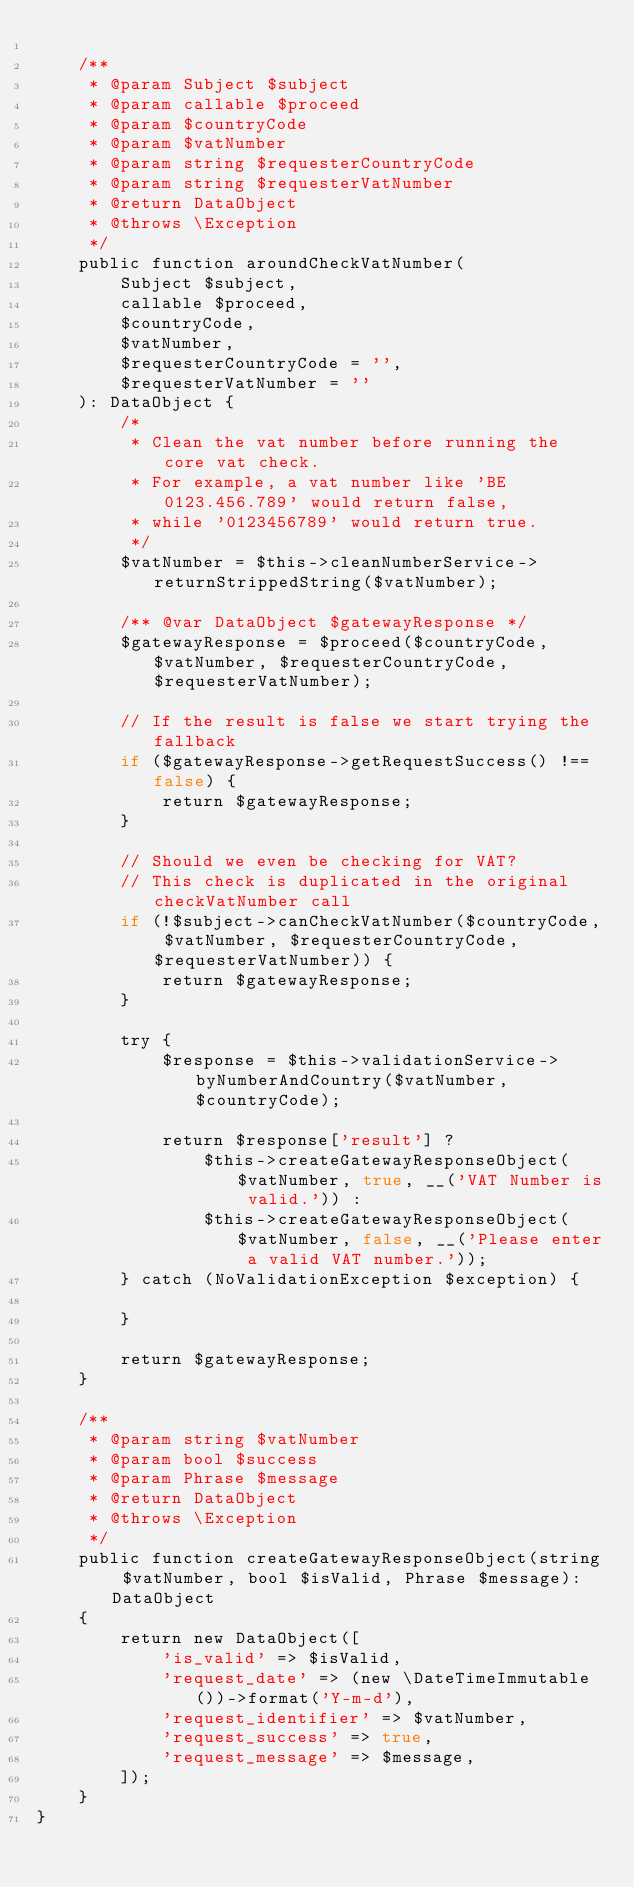Convert code to text. <code><loc_0><loc_0><loc_500><loc_500><_PHP_>
    /**
     * @param Subject $subject
     * @param callable $proceed
     * @param $countryCode
     * @param $vatNumber
     * @param string $requesterCountryCode
     * @param string $requesterVatNumber
     * @return DataObject
     * @throws \Exception
     */
    public function aroundCheckVatNumber(
        Subject $subject,
        callable $proceed,
        $countryCode,
        $vatNumber,
        $requesterCountryCode = '',
        $requesterVatNumber = ''
    ): DataObject {
        /*
         * Clean the vat number before running the core vat check.
         * For example, a vat number like 'BE 0123.456.789' would return false,
         * while '0123456789' would return true.
         */
        $vatNumber = $this->cleanNumberService->returnStrippedString($vatNumber);

        /** @var DataObject $gatewayResponse */
        $gatewayResponse = $proceed($countryCode, $vatNumber, $requesterCountryCode, $requesterVatNumber);

        // If the result is false we start trying the fallback
        if ($gatewayResponse->getRequestSuccess() !== false) {
            return $gatewayResponse;
        }

        // Should we even be checking for VAT?
        // This check is duplicated in the original checkVatNumber call
        if (!$subject->canCheckVatNumber($countryCode, $vatNumber, $requesterCountryCode, $requesterVatNumber)) {
            return $gatewayResponse;
        }

        try {
            $response = $this->validationService->byNumberAndCountry($vatNumber, $countryCode);

            return $response['result'] ?
                $this->createGatewayResponseObject($vatNumber, true, __('VAT Number is valid.')) :
                $this->createGatewayResponseObject($vatNumber, false, __('Please enter a valid VAT number.'));
        } catch (NoValidationException $exception) {

        }

        return $gatewayResponse;
    }

    /**
     * @param string $vatNumber
     * @param bool $success
     * @param Phrase $message
     * @return DataObject
     * @throws \Exception
     */
    public function createGatewayResponseObject(string $vatNumber, bool $isValid, Phrase $message): DataObject
    {
        return new DataObject([
            'is_valid' => $isValid,
            'request_date' => (new \DateTimeImmutable())->format('Y-m-d'),
            'request_identifier' => $vatNumber,
            'request_success' => true,
            'request_message' => $message,
        ]);
    }
}
</code> 